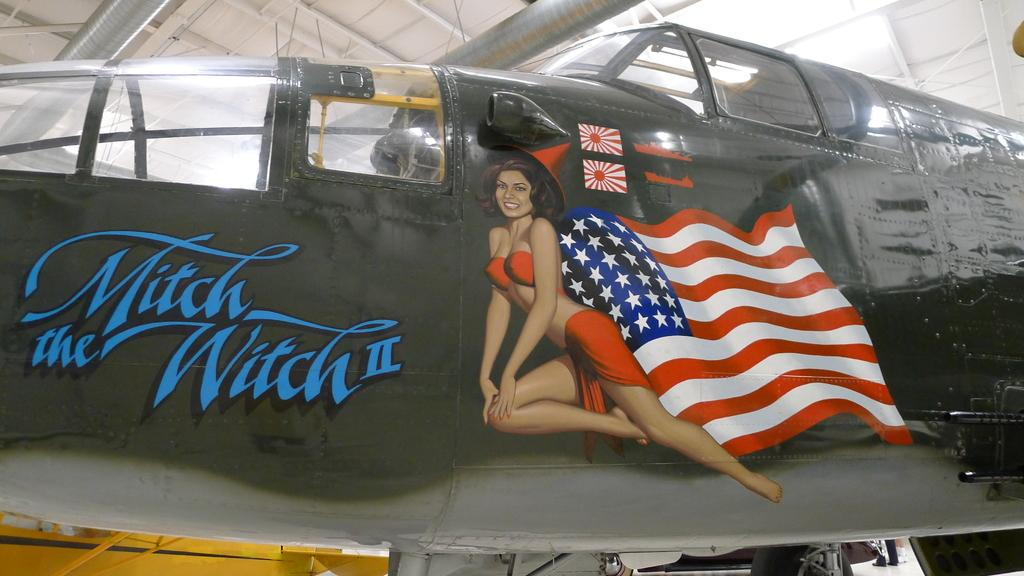<image>
Describe the image concisely. An airplane named Mitch the Witch has a picture of a woman painted on it. 